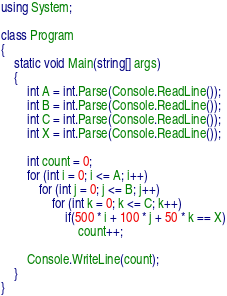<code> <loc_0><loc_0><loc_500><loc_500><_C#_>using System;

class Program
{
    static void Main(string[] args)
    {
        int A = int.Parse(Console.ReadLine());
        int B = int.Parse(Console.ReadLine());
        int C = int.Parse(Console.ReadLine());
        int X = int.Parse(Console.ReadLine());

        int count = 0;
        for (int i = 0; i <= A; i++)
            for (int j = 0; j <= B; j++)
                for (int k = 0; k <= C; k++)
                    if(500 * i + 100 * j + 50 * k == X)
                        count++;

        Console.WriteLine(count);
    }
}</code> 